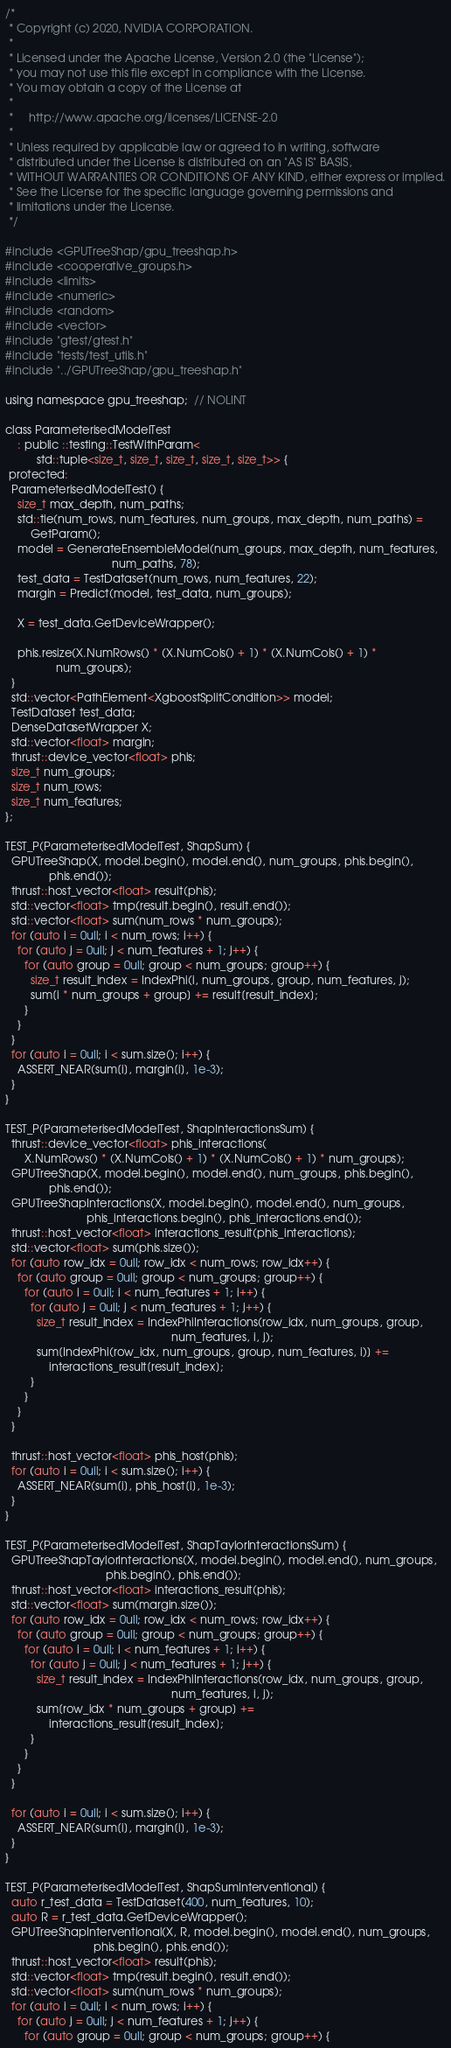Convert code to text. <code><loc_0><loc_0><loc_500><loc_500><_Cuda_>/*
 * Copyright (c) 2020, NVIDIA CORPORATION.
 *
 * Licensed under the Apache License, Version 2.0 (the "License");
 * you may not use this file except in compliance with the License.
 * You may obtain a copy of the License at
 *
 *     http://www.apache.org/licenses/LICENSE-2.0
 *
 * Unless required by applicable law or agreed to in writing, software
 * distributed under the License is distributed on an "AS IS" BASIS,
 * WITHOUT WARRANTIES OR CONDITIONS OF ANY KIND, either express or implied.
 * See the License for the specific language governing permissions and
 * limitations under the License.
 */

#include <GPUTreeShap/gpu_treeshap.h>
#include <cooperative_groups.h>
#include <limits>
#include <numeric>
#include <random>
#include <vector>
#include "gtest/gtest.h"
#include "tests/test_utils.h"
#include "../GPUTreeShap/gpu_treeshap.h"

using namespace gpu_treeshap;  // NOLINT

class ParameterisedModelTest
    : public ::testing::TestWithParam<
          std::tuple<size_t, size_t, size_t, size_t, size_t>> {
 protected:
  ParameterisedModelTest() {
    size_t max_depth, num_paths;
    std::tie(num_rows, num_features, num_groups, max_depth, num_paths) =
        GetParam();
    model = GenerateEnsembleModel(num_groups, max_depth, num_features,
                                  num_paths, 78);
    test_data = TestDataset(num_rows, num_features, 22);
    margin = Predict(model, test_data, num_groups);

    X = test_data.GetDeviceWrapper();

    phis.resize(X.NumRows() * (X.NumCols() + 1) * (X.NumCols() + 1) *
                num_groups);
  }
  std::vector<PathElement<XgboostSplitCondition>> model;
  TestDataset test_data;
  DenseDatasetWrapper X;
  std::vector<float> margin;
  thrust::device_vector<float> phis;
  size_t num_groups;
  size_t num_rows;
  size_t num_features;
};

TEST_P(ParameterisedModelTest, ShapSum) {
  GPUTreeShap(X, model.begin(), model.end(), num_groups, phis.begin(),
              phis.end());
  thrust::host_vector<float> result(phis);
  std::vector<float> tmp(result.begin(), result.end());
  std::vector<float> sum(num_rows * num_groups);
  for (auto i = 0ull; i < num_rows; i++) {
    for (auto j = 0ull; j < num_features + 1; j++) {
      for (auto group = 0ull; group < num_groups; group++) {
        size_t result_index = IndexPhi(i, num_groups, group, num_features, j);
        sum[i * num_groups + group] += result[result_index];
      }
    }
  }
  for (auto i = 0ull; i < sum.size(); i++) {
    ASSERT_NEAR(sum[i], margin[i], 1e-3);
  }
}

TEST_P(ParameterisedModelTest, ShapInteractionsSum) {
  thrust::device_vector<float> phis_interactions(
      X.NumRows() * (X.NumCols() + 1) * (X.NumCols() + 1) * num_groups);
  GPUTreeShap(X, model.begin(), model.end(), num_groups, phis.begin(),
              phis.end());
  GPUTreeShapInteractions(X, model.begin(), model.end(), num_groups,
                          phis_interactions.begin(), phis_interactions.end());
  thrust::host_vector<float> interactions_result(phis_interactions);
  std::vector<float> sum(phis.size());
  for (auto row_idx = 0ull; row_idx < num_rows; row_idx++) {
    for (auto group = 0ull; group < num_groups; group++) {
      for (auto i = 0ull; i < num_features + 1; i++) {
        for (auto j = 0ull; j < num_features + 1; j++) {
          size_t result_index = IndexPhiInteractions(row_idx, num_groups, group,
                                                     num_features, i, j);
          sum[IndexPhi(row_idx, num_groups, group, num_features, i)] +=
              interactions_result[result_index];
        }
      }
    }
  }

  thrust::host_vector<float> phis_host(phis);
  for (auto i = 0ull; i < sum.size(); i++) {
    ASSERT_NEAR(sum[i], phis_host[i], 1e-3);
  }
}

TEST_P(ParameterisedModelTest, ShapTaylorInteractionsSum) {
  GPUTreeShapTaylorInteractions(X, model.begin(), model.end(), num_groups,
                                phis.begin(), phis.end());
  thrust::host_vector<float> interactions_result(phis);
  std::vector<float> sum(margin.size());
  for (auto row_idx = 0ull; row_idx < num_rows; row_idx++) {
    for (auto group = 0ull; group < num_groups; group++) {
      for (auto i = 0ull; i < num_features + 1; i++) {
        for (auto j = 0ull; j < num_features + 1; j++) {
          size_t result_index = IndexPhiInteractions(row_idx, num_groups, group,
                                                     num_features, i, j);
          sum[row_idx * num_groups + group] +=
              interactions_result[result_index];
        }
      }
    }
  }

  for (auto i = 0ull; i < sum.size(); i++) {
    ASSERT_NEAR(sum[i], margin[i], 1e-3);
  }
}

TEST_P(ParameterisedModelTest, ShapSumInterventional) {
  auto r_test_data = TestDataset(400, num_features, 10);
  auto R = r_test_data.GetDeviceWrapper();
  GPUTreeShapInterventional(X, R, model.begin(), model.end(), num_groups,
                            phis.begin(), phis.end());
  thrust::host_vector<float> result(phis);
  std::vector<float> tmp(result.begin(), result.end());
  std::vector<float> sum(num_rows * num_groups);
  for (auto i = 0ull; i < num_rows; i++) {
    for (auto j = 0ull; j < num_features + 1; j++) {
      for (auto group = 0ull; group < num_groups; group++) {</code> 